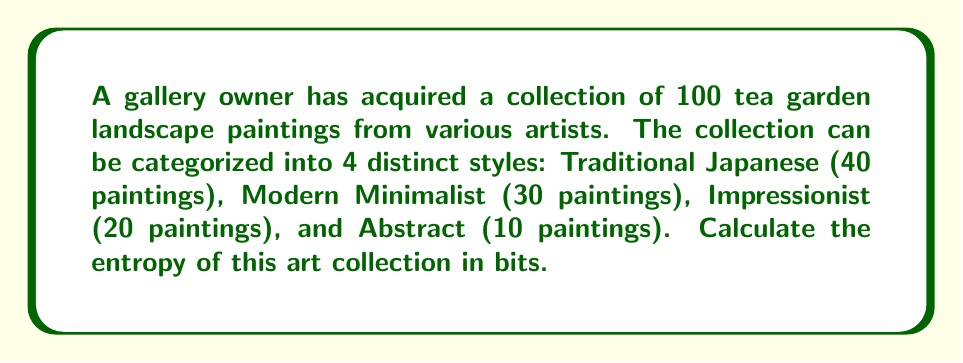Can you solve this math problem? To calculate the entropy of the art collection, we'll use the Shannon entropy formula:

$$S = -\sum_{i=1}^{n} p_i \log_2(p_i)$$

Where:
$S$ is the entropy in bits
$p_i$ is the probability of each style
$n$ is the number of distinct styles

Step 1: Calculate the probabilities for each style:
Traditional Japanese: $p_1 = 40/100 = 0.4$
Modern Minimalist: $p_2 = 30/100 = 0.3$
Impressionist: $p_3 = 20/100 = 0.2$
Abstract: $p_4 = 10/100 = 0.1$

Step 2: Apply the entropy formula:

$$\begin{align}
S &= -[0.4 \log_2(0.4) + 0.3 \log_2(0.3) + 0.2 \log_2(0.2) + 0.1 \log_2(0.1)] \\
&= -[0.4 \cdot (-1.322) + 0.3 \cdot (-1.737) + 0.2 \cdot (-2.322) + 0.1 \cdot (-3.322)] \\
&= -[-0.5288 - 0.5211 - 0.4644 - 0.3322] \\
&= 1.8465
\end{align}$$

Step 3: Round the result to three decimal places.
Answer: 1.847 bits 